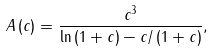<formula> <loc_0><loc_0><loc_500><loc_500>A \left ( c \right ) = \frac { c ^ { 3 } } { \ln { \left ( 1 + c \right ) - c / \left ( 1 + c \right ) } } ,</formula> 